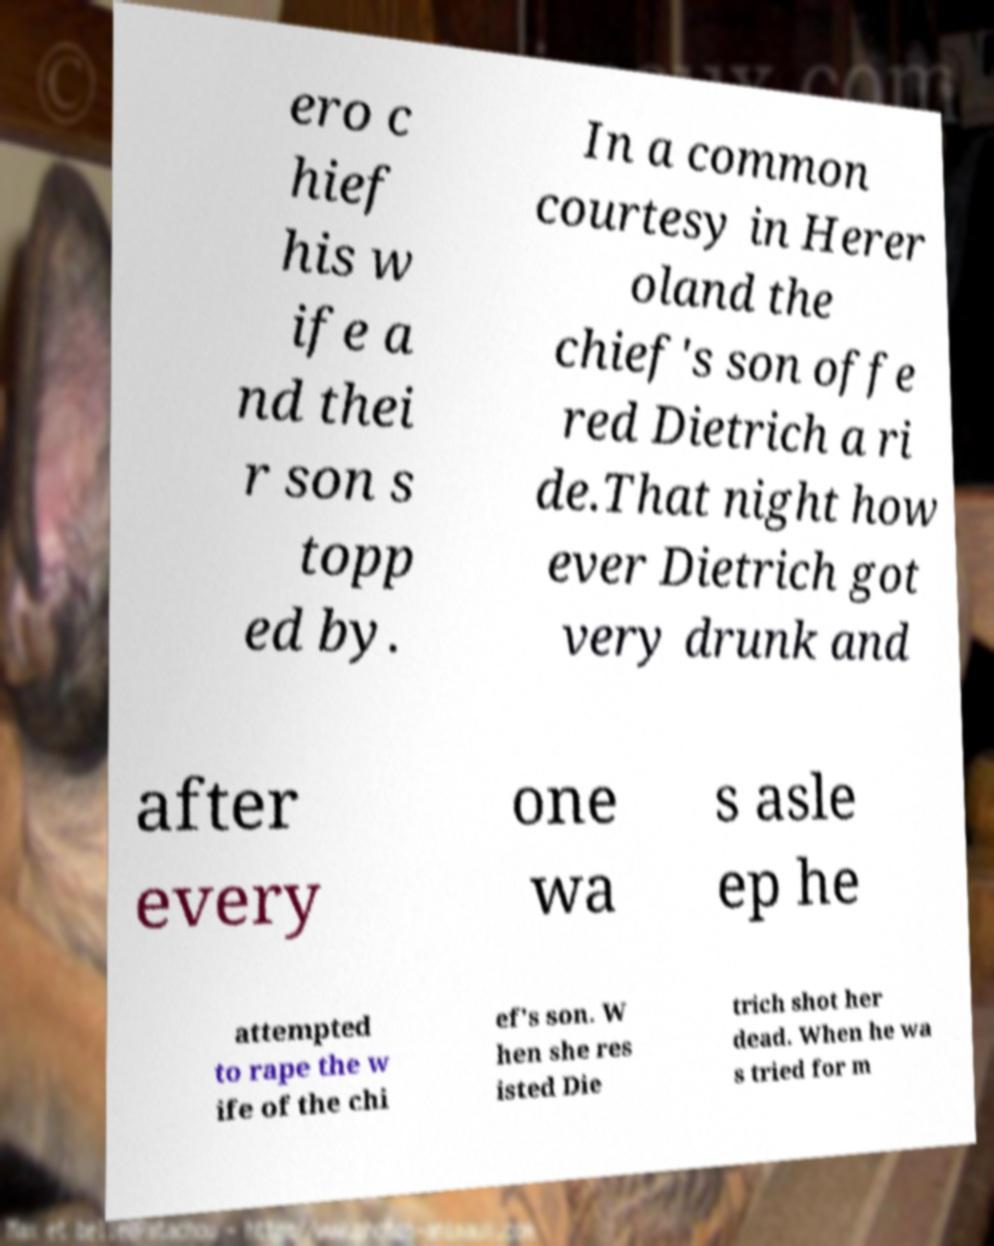Could you extract and type out the text from this image? ero c hief his w ife a nd thei r son s topp ed by. In a common courtesy in Herer oland the chief's son offe red Dietrich a ri de.That night how ever Dietrich got very drunk and after every one wa s asle ep he attempted to rape the w ife of the chi ef's son. W hen she res isted Die trich shot her dead. When he wa s tried for m 